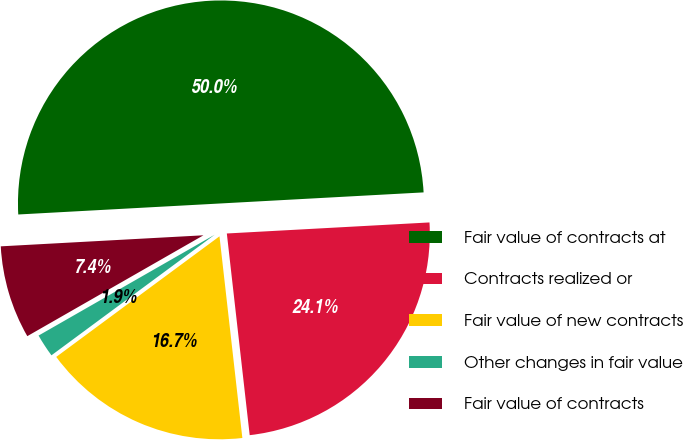<chart> <loc_0><loc_0><loc_500><loc_500><pie_chart><fcel>Fair value of contracts at<fcel>Contracts realized or<fcel>Fair value of new contracts<fcel>Other changes in fair value<fcel>Fair value of contracts<nl><fcel>50.0%<fcel>24.07%<fcel>16.67%<fcel>1.85%<fcel>7.41%<nl></chart> 